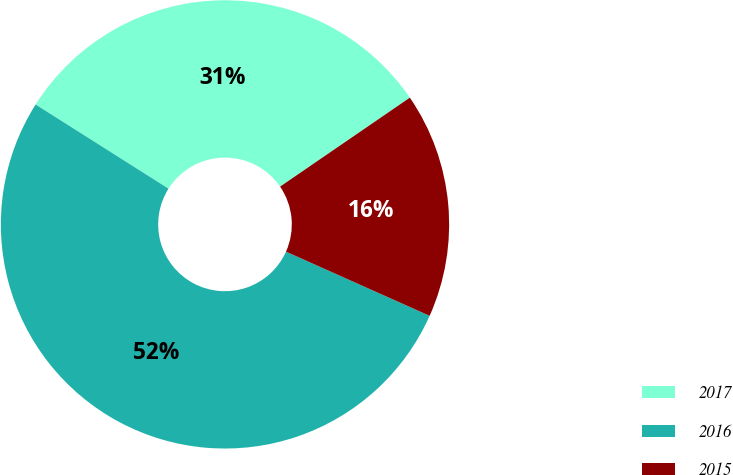<chart> <loc_0><loc_0><loc_500><loc_500><pie_chart><fcel>2017<fcel>2016<fcel>2015<nl><fcel>31.45%<fcel>52.29%<fcel>16.25%<nl></chart> 